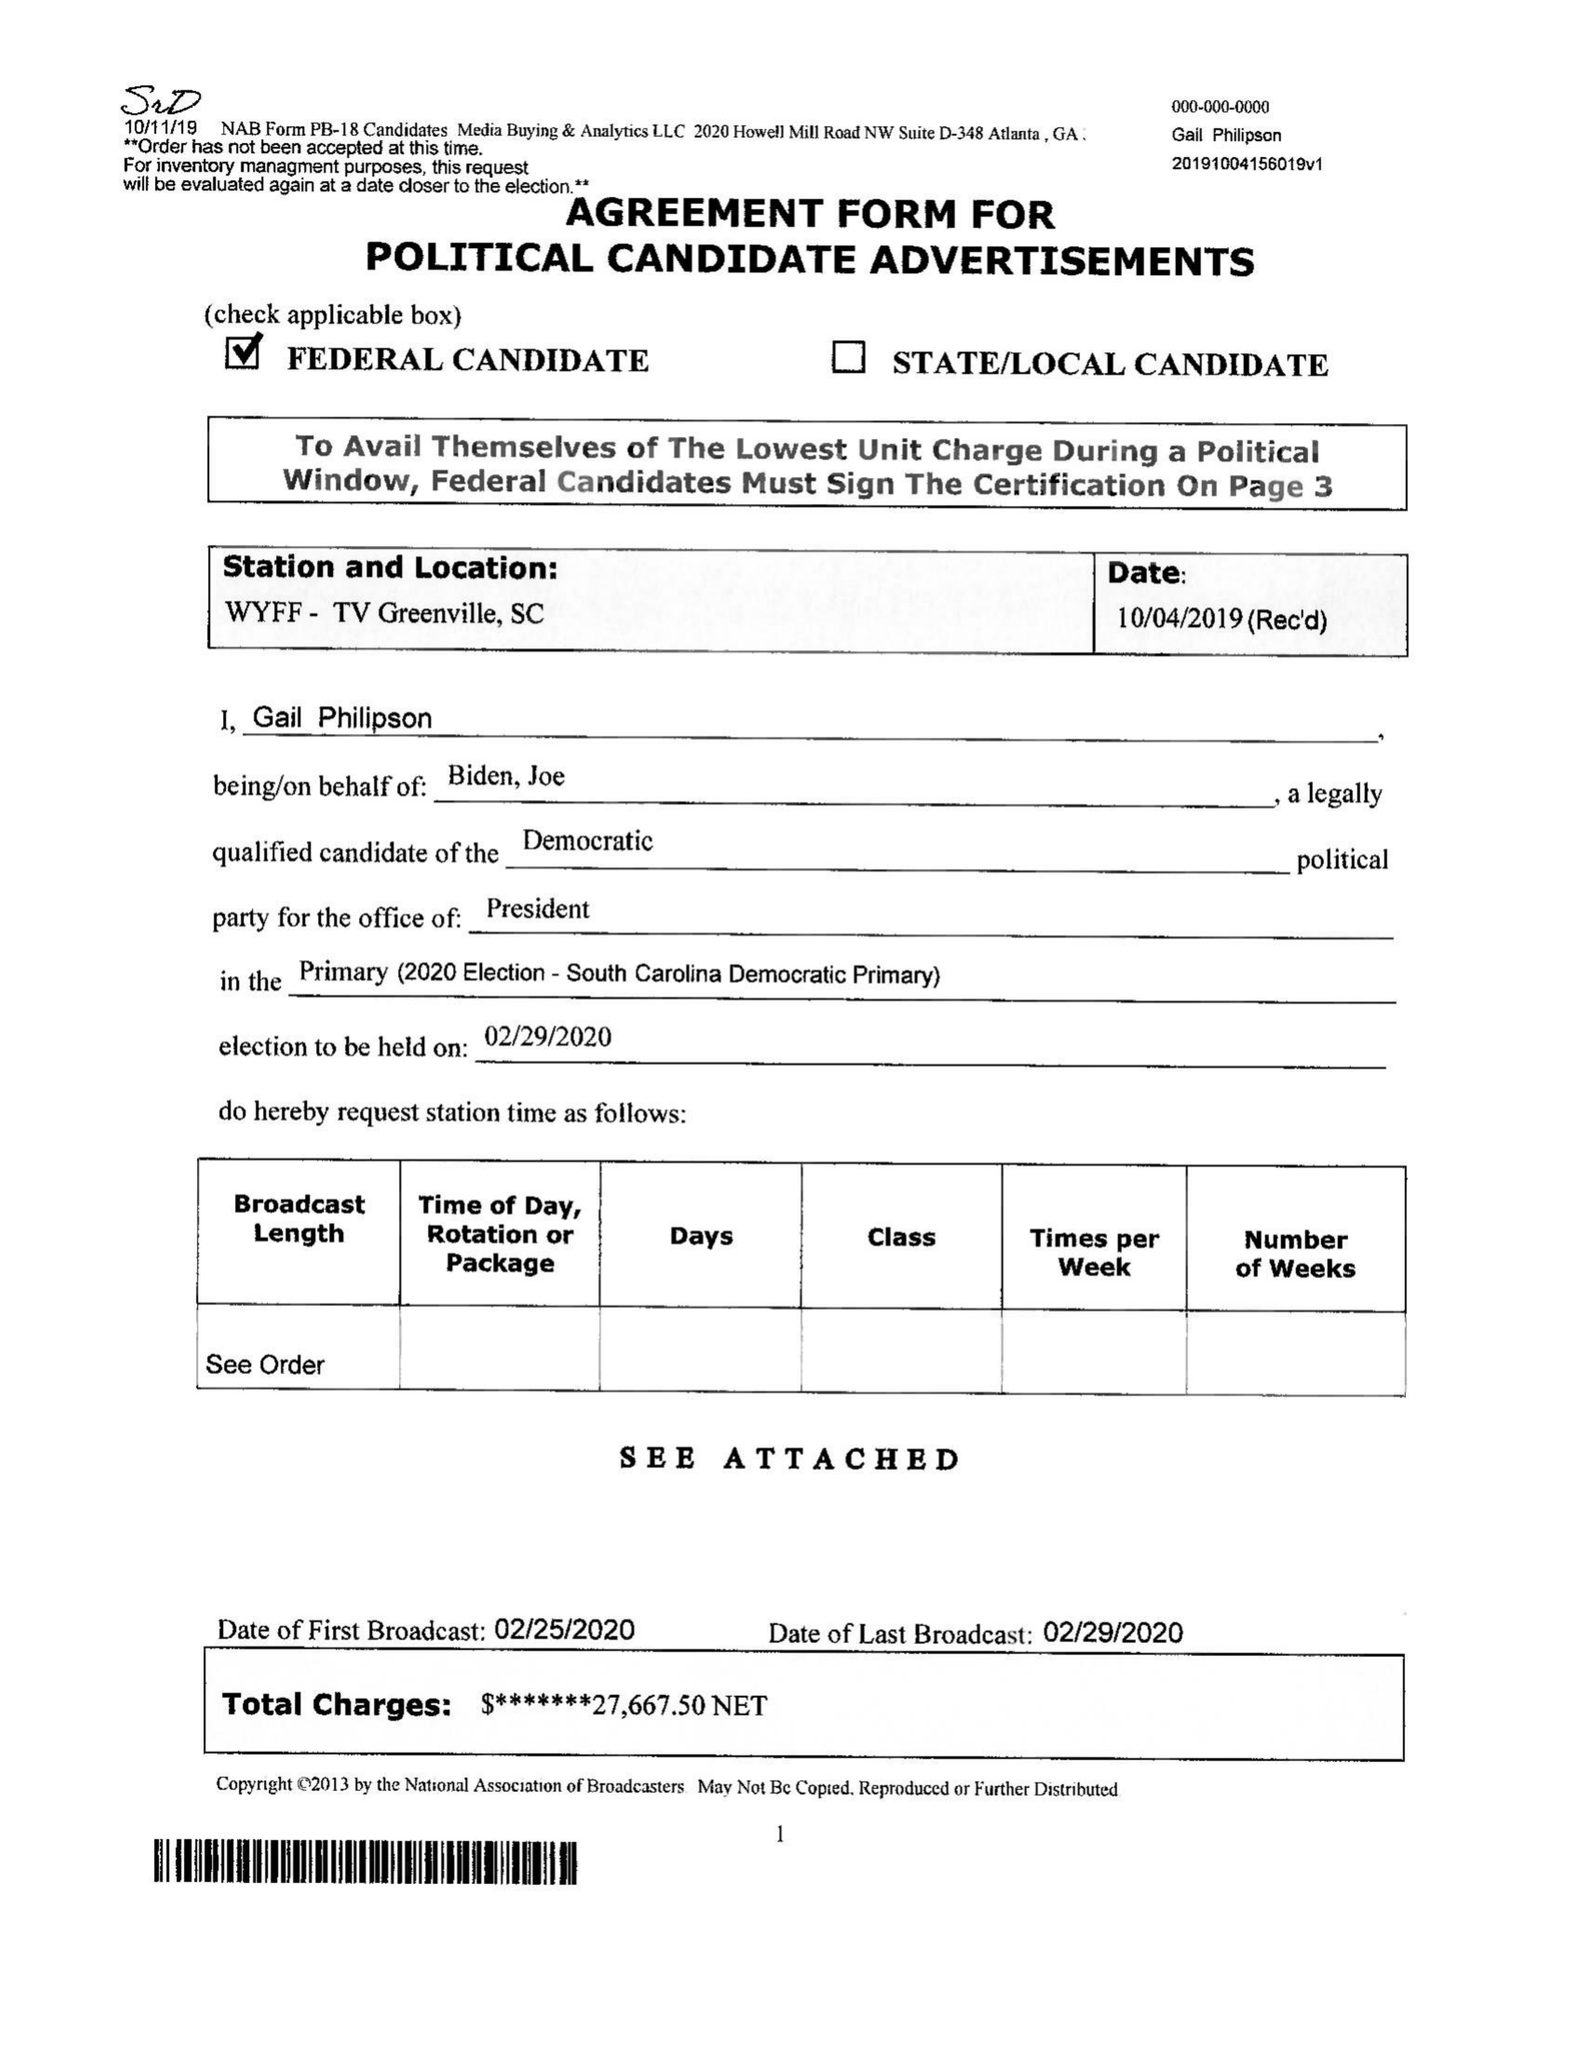What is the value for the flight_to?
Answer the question using a single word or phrase. 02/29/20 